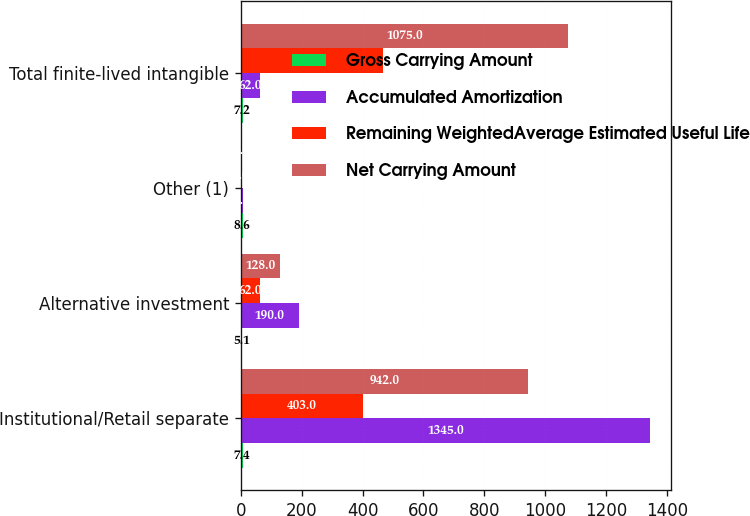<chart> <loc_0><loc_0><loc_500><loc_500><stacked_bar_chart><ecel><fcel>Institutional/Retail separate<fcel>Alternative investment<fcel>Other (1)<fcel>Total finite-lived intangible<nl><fcel>Gross Carrying Amount<fcel>7.4<fcel>5.1<fcel>8.6<fcel>7.2<nl><fcel>Accumulated Amortization<fcel>1345<fcel>190<fcel>6<fcel>62<nl><fcel>Remaining WeightedAverage Estimated Useful Life<fcel>403<fcel>62<fcel>1<fcel>466<nl><fcel>Net Carrying Amount<fcel>942<fcel>128<fcel>5<fcel>1075<nl></chart> 